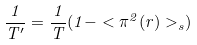Convert formula to latex. <formula><loc_0><loc_0><loc_500><loc_500>\frac { 1 } { T ^ { \prime } } = \frac { 1 } { T } ( 1 - < \pi ^ { 2 } ( { r } ) > _ { s } )</formula> 